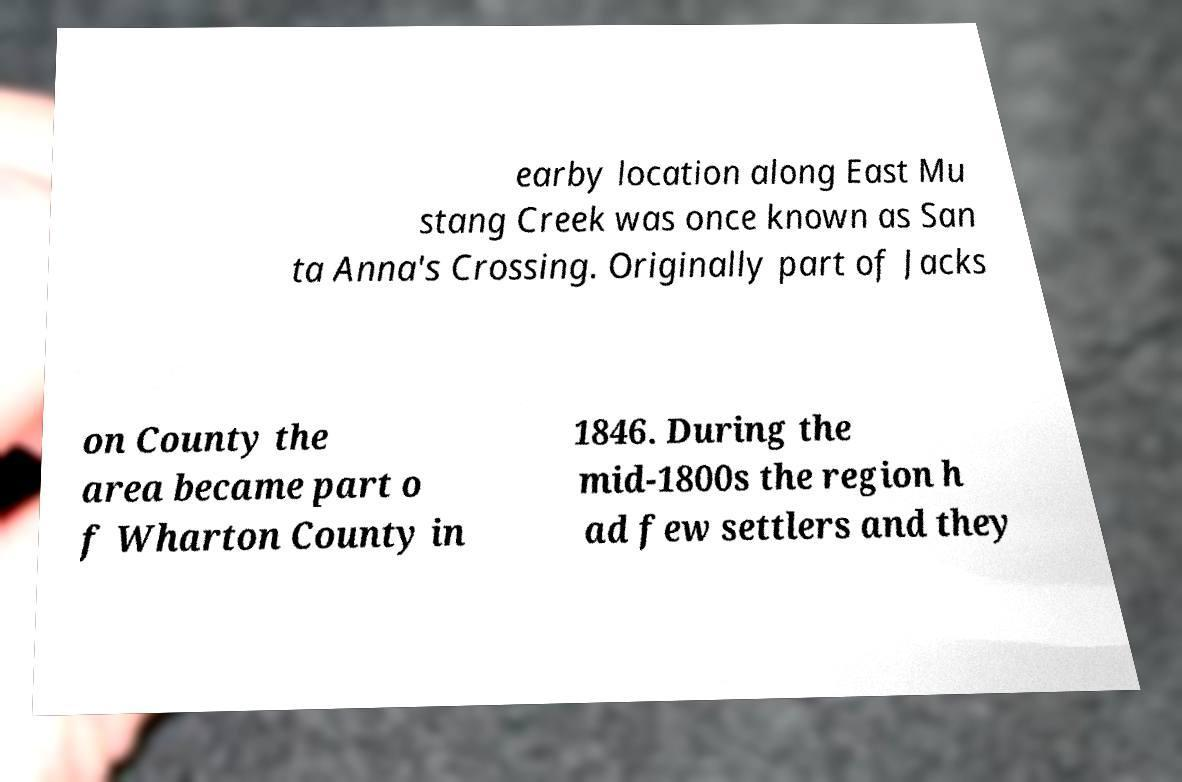I need the written content from this picture converted into text. Can you do that? earby location along East Mu stang Creek was once known as San ta Anna's Crossing. Originally part of Jacks on County the area became part o f Wharton County in 1846. During the mid-1800s the region h ad few settlers and they 